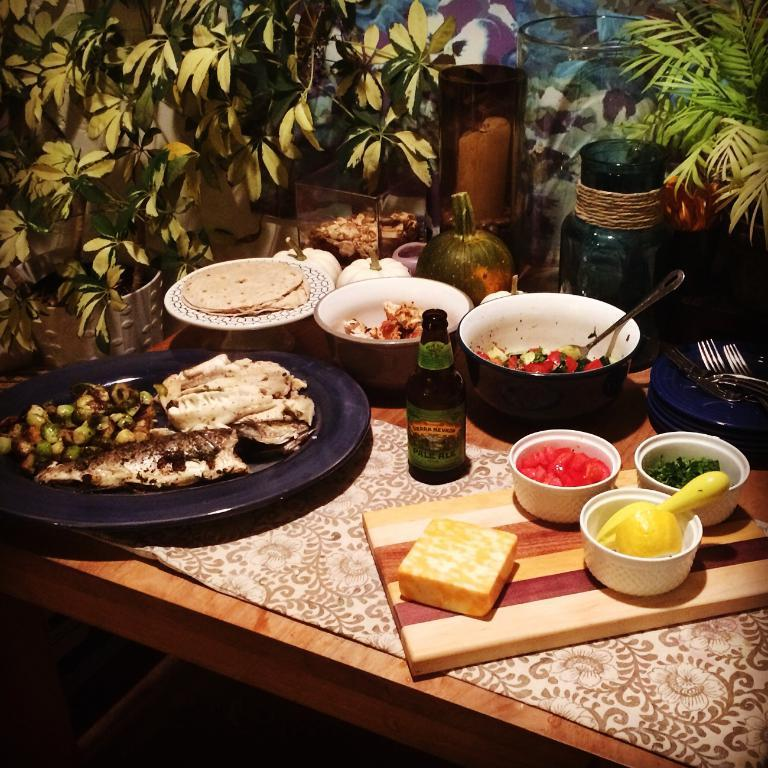What type of food container is visible in the image? There is a bottle of food in the image. What other types of containers are present in the image? There are bowls and cups in the image. Are there any plants visible in the image? Yes, there are trees on the table in the image. What type of police machine can be seen in the image? There is no police machine present in the image. What flavor of mint is visible in the image? There is no mint present in the image. 